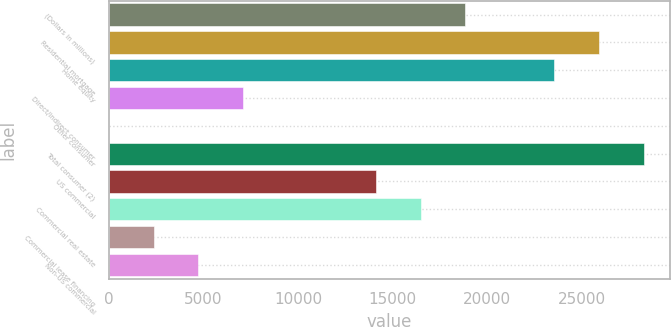<chart> <loc_0><loc_0><loc_500><loc_500><bar_chart><fcel>(Dollars in millions)<fcel>Residential mortgage<fcel>Home equity<fcel>Direct/Indirect consumer<fcel>Other consumer<fcel>Total consumer (2)<fcel>US commercial<fcel>Commercial real estate<fcel>Commercial lease financing<fcel>Non-US commercial<nl><fcel>18844.4<fcel>25910.3<fcel>23555<fcel>7067.9<fcel>2<fcel>28265.6<fcel>14133.8<fcel>16489.1<fcel>2357.3<fcel>4712.6<nl></chart> 